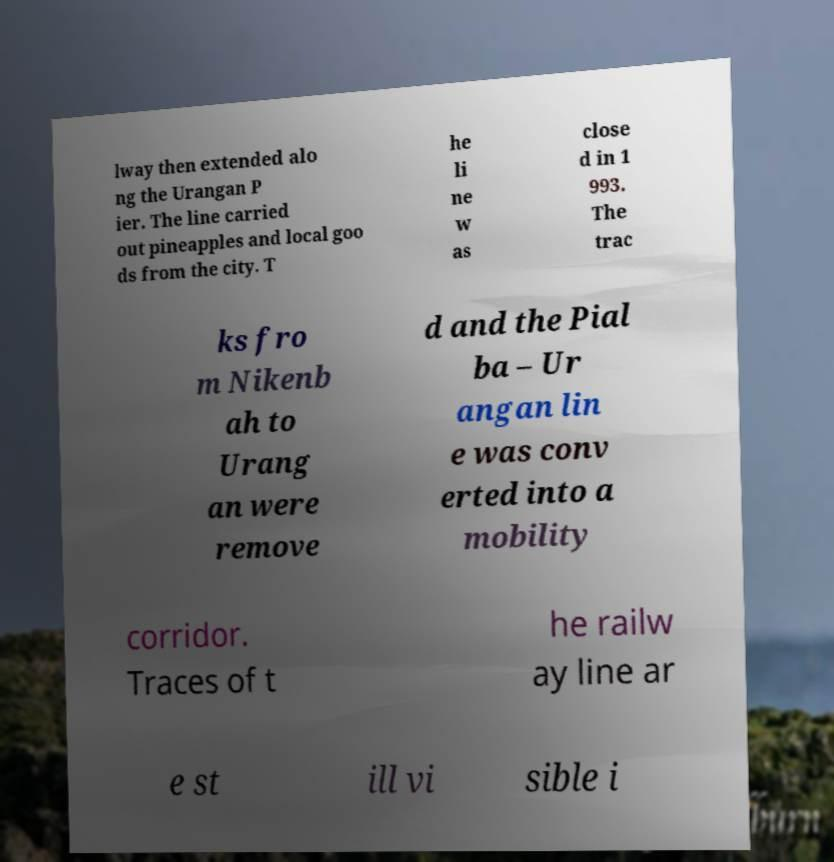What messages or text are displayed in this image? I need them in a readable, typed format. lway then extended alo ng the Urangan P ier. The line carried out pineapples and local goo ds from the city. T he li ne w as close d in 1 993. The trac ks fro m Nikenb ah to Urang an were remove d and the Pial ba – Ur angan lin e was conv erted into a mobility corridor. Traces of t he railw ay line ar e st ill vi sible i 